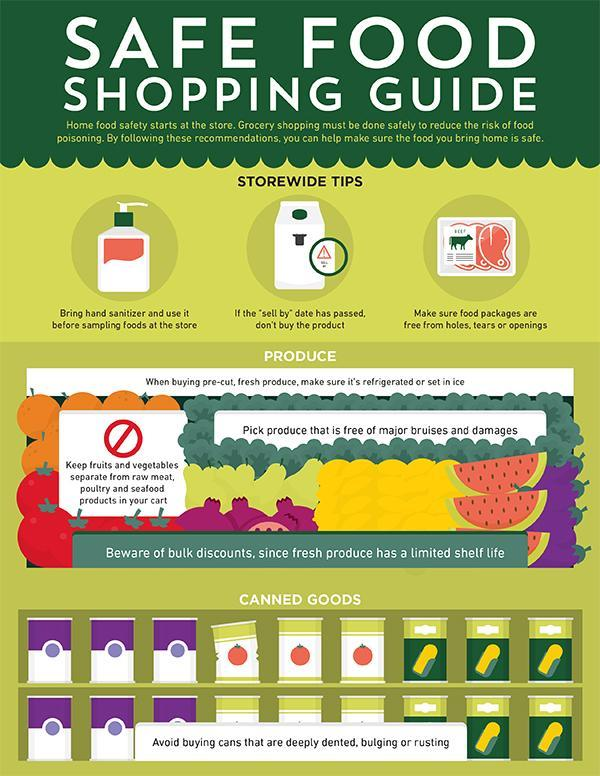What is written on the packet of meat?
Answer the question with a short phrase. BEEF Under which category of food would one find packaged food items, canned goods, cereals, or fresh produce? canned goods Under which category would one find fruits and vegetables, cereals, fresh produce, or canned goods? fresh produce 